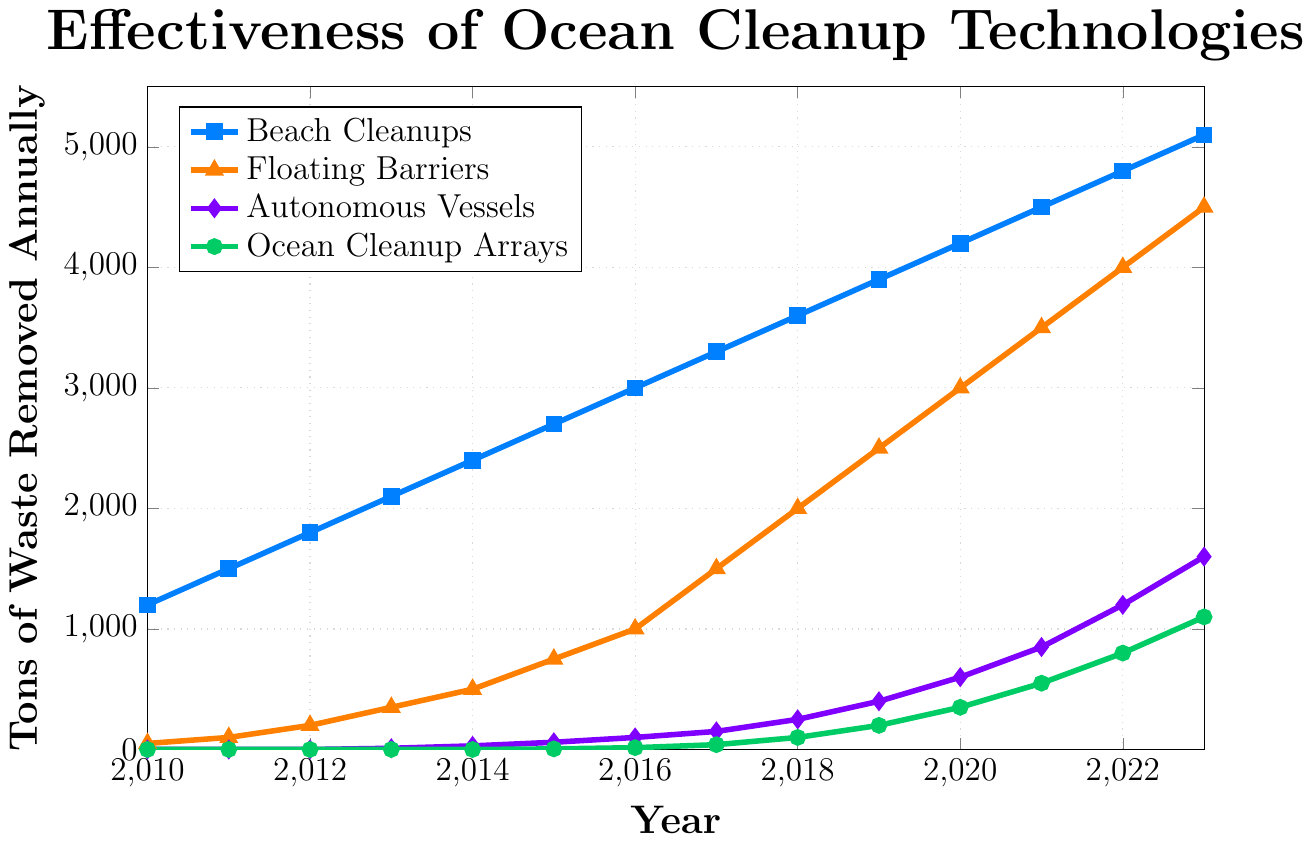Which technology removed the most waste in 2023? Look for the highest value on the y-axis in the year 2023. The plot shows "Beach Cleanups" at 5100 tons of waste removed.
Answer: Beach Cleanups How much more waste was removed by Floating Barriers compared to Beach Cleanups in 2020? Find the values for Floating Barriers and Beach Cleanups in 2020. Floating Barriers removed 3000 tons, and Beach Cleanups removed 4200 tons. The difference is 4200 - 3000 = 1200 tons.
Answer: 1200 tons Which technology showed the steepest increase in waste removal from 2019 to 2023? Calculate the differences for each technology between 2023 and 2019: 
- Beach Cleanups: 5100 - 3900 = 1200 
- Floating Barriers: 4500 - 2500 = 2000 
- Autonomous Vessels: 1600 - 400 = 1200 
- Ocean Cleanup Arrays: 1100 - 200 = 900 
The largest increase is 2000 for Floating Barriers.
Answer: Floating Barriers What was the cumulative waste removed by all technologies in 2015? Sum the waste removed by each technology in 2015: 
- Beach Cleanups: 2700 
- Floating Barriers: 750 
- Autonomous Vessels: 60 
- Ocean Cleanup Arrays: 5 
The total is 2700 + 750 + 60 + 5 = 3515 tons.
Answer: 3515 tons Which year marked the first removal of waste by Ocean Cleanup Arrays? Identify the earliest non-zero value for Ocean Cleanup Arrays, which is in 2015.
Answer: 2015 By how much did waste removal by Autonomous Vessels increase between 2017 and 2021? Subtract the value in 2017 (150 tons) from the value in 2021 (850 tons): 850 - 150 = 700 tons.
Answer: 700 tons Which technology had zero waste removal in the first three years (2010-2012)? Check which technologies have a value of zero for 2010, 2011, and 2012. Autonomous Vessels and Ocean Cleanup Arrays both had zero waste removal in these years.
Answer: Autonomous Vessels and Ocean Cleanup Arrays What was the average annual waste removal by Floating Barriers from 2014 to 2016? Calculate the average for Floating Barriers from 2014 to 2016:
- 2014: 500 
- 2015: 750 
- 2016: 1000 
Average = (500 + 750 + 1000) / 3 = 2250 / 3 = 750 tons.
Answer: 750 tons In which year did Beach Cleanups surpass 3000 tons of waste removal for the first time? Find the first year when the value for Beach Cleanups exceeded 3000. This happens in 2016 with 3000 tons.
Answer: 2016 